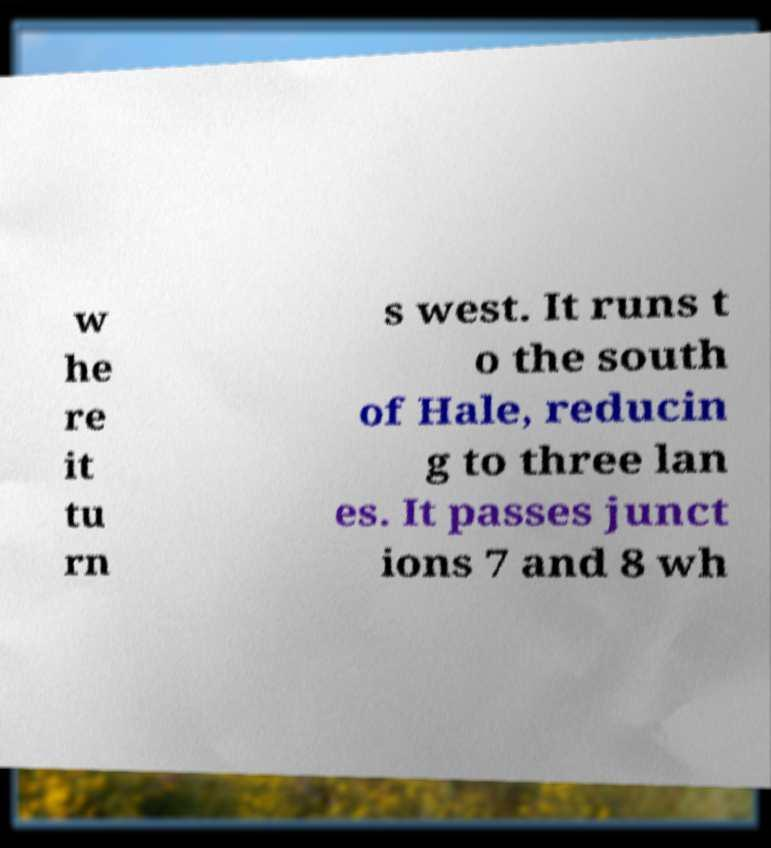What messages or text are displayed in this image? I need them in a readable, typed format. w he re it tu rn s west. It runs t o the south of Hale, reducin g to three lan es. It passes junct ions 7 and 8 wh 